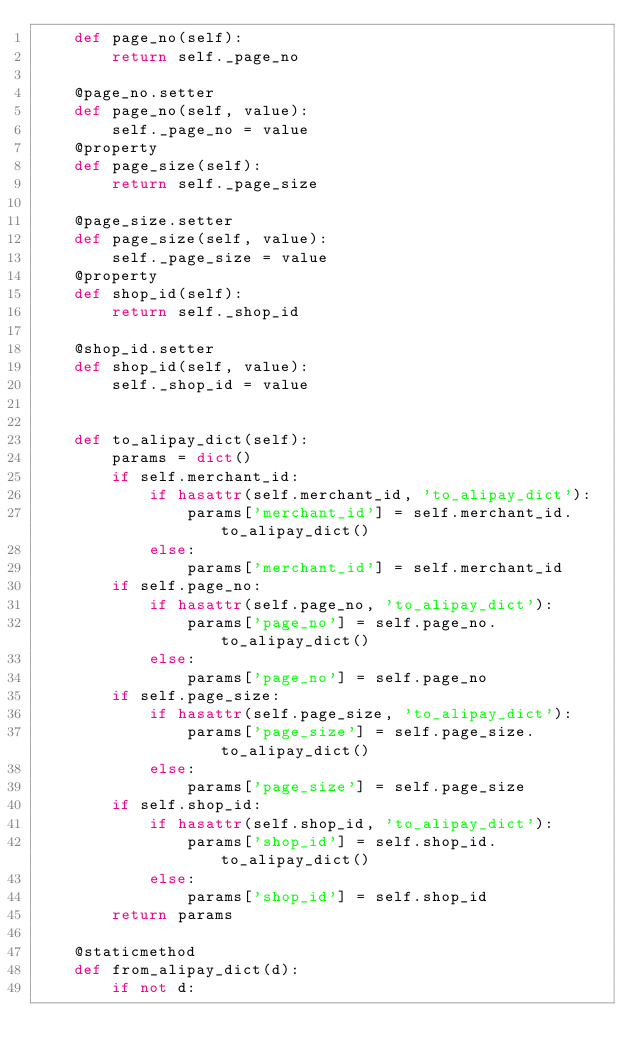Convert code to text. <code><loc_0><loc_0><loc_500><loc_500><_Python_>    def page_no(self):
        return self._page_no

    @page_no.setter
    def page_no(self, value):
        self._page_no = value
    @property
    def page_size(self):
        return self._page_size

    @page_size.setter
    def page_size(self, value):
        self._page_size = value
    @property
    def shop_id(self):
        return self._shop_id

    @shop_id.setter
    def shop_id(self, value):
        self._shop_id = value


    def to_alipay_dict(self):
        params = dict()
        if self.merchant_id:
            if hasattr(self.merchant_id, 'to_alipay_dict'):
                params['merchant_id'] = self.merchant_id.to_alipay_dict()
            else:
                params['merchant_id'] = self.merchant_id
        if self.page_no:
            if hasattr(self.page_no, 'to_alipay_dict'):
                params['page_no'] = self.page_no.to_alipay_dict()
            else:
                params['page_no'] = self.page_no
        if self.page_size:
            if hasattr(self.page_size, 'to_alipay_dict'):
                params['page_size'] = self.page_size.to_alipay_dict()
            else:
                params['page_size'] = self.page_size
        if self.shop_id:
            if hasattr(self.shop_id, 'to_alipay_dict'):
                params['shop_id'] = self.shop_id.to_alipay_dict()
            else:
                params['shop_id'] = self.shop_id
        return params

    @staticmethod
    def from_alipay_dict(d):
        if not d:</code> 